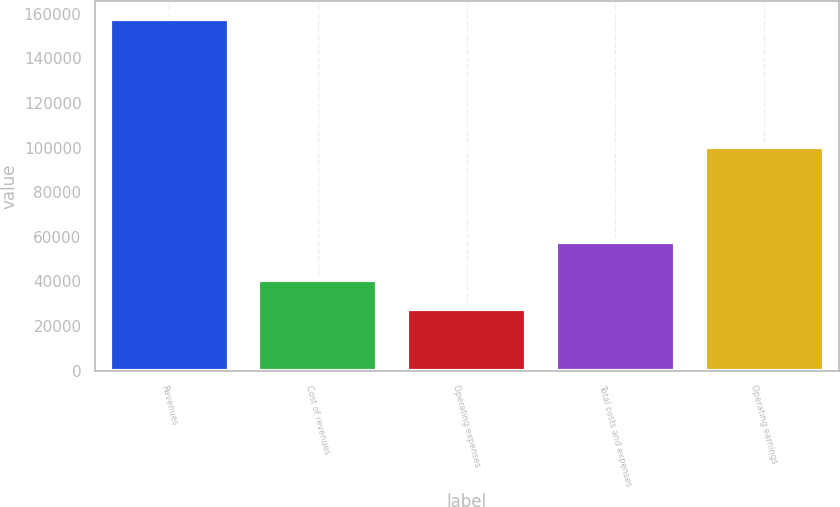<chart> <loc_0><loc_0><loc_500><loc_500><bar_chart><fcel>Revenues<fcel>Cost of revenues<fcel>Operating expenses<fcel>Total costs and expenses<fcel>Operating earnings<nl><fcel>157627<fcel>40682.8<fcel>27689<fcel>57494<fcel>100133<nl></chart> 